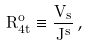Convert formula to latex. <formula><loc_0><loc_0><loc_500><loc_500>R ^ { o } _ { 4 t } \equiv \frac { V _ { s } } { J ^ { s } } \, ,</formula> 